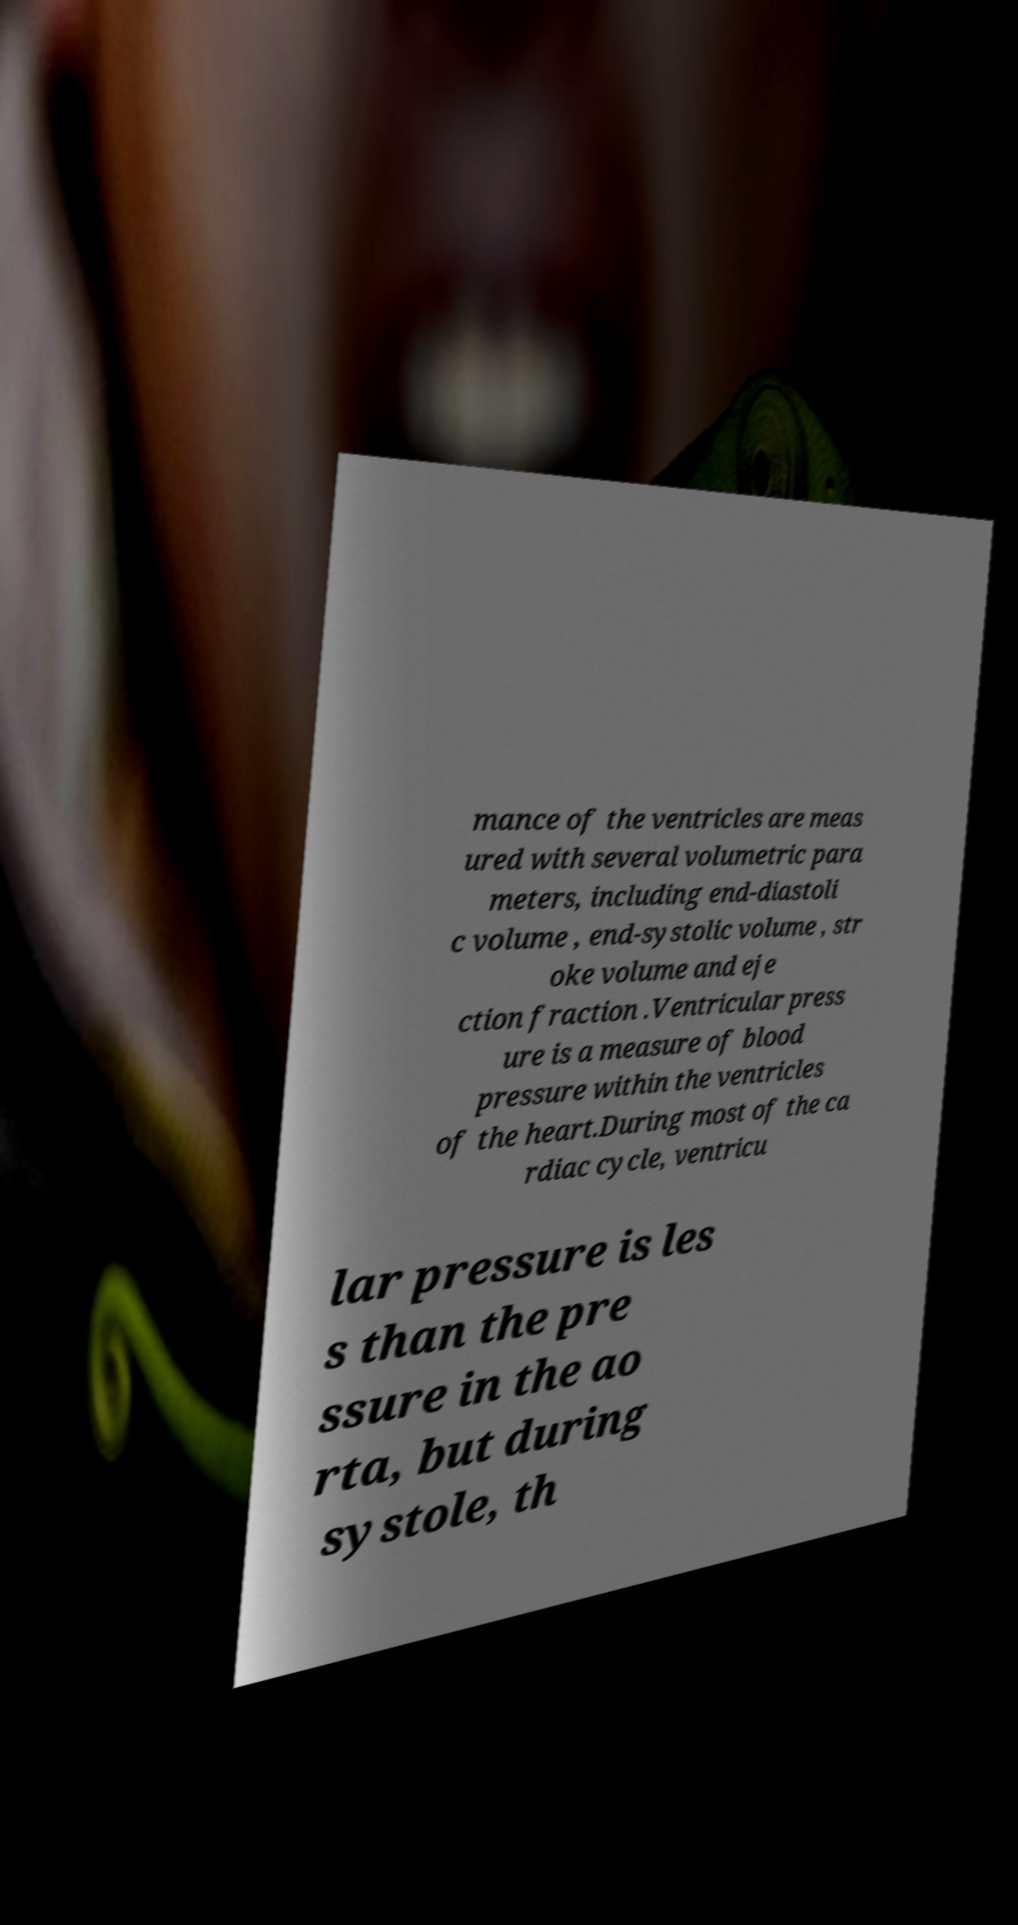For documentation purposes, I need the text within this image transcribed. Could you provide that? mance of the ventricles are meas ured with several volumetric para meters, including end-diastoli c volume , end-systolic volume , str oke volume and eje ction fraction .Ventricular press ure is a measure of blood pressure within the ventricles of the heart.During most of the ca rdiac cycle, ventricu lar pressure is les s than the pre ssure in the ao rta, but during systole, th 